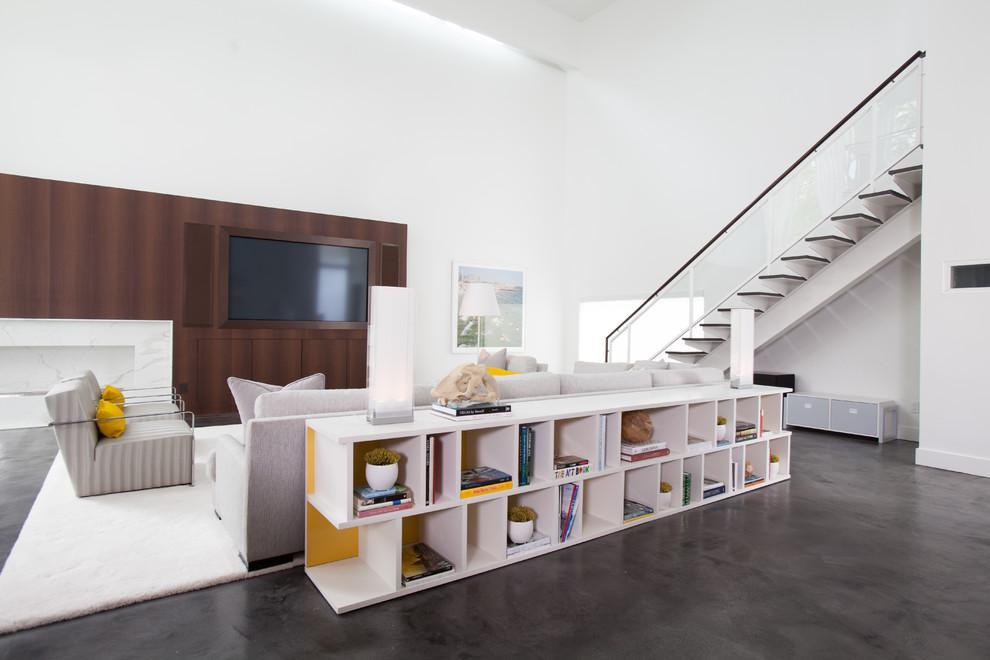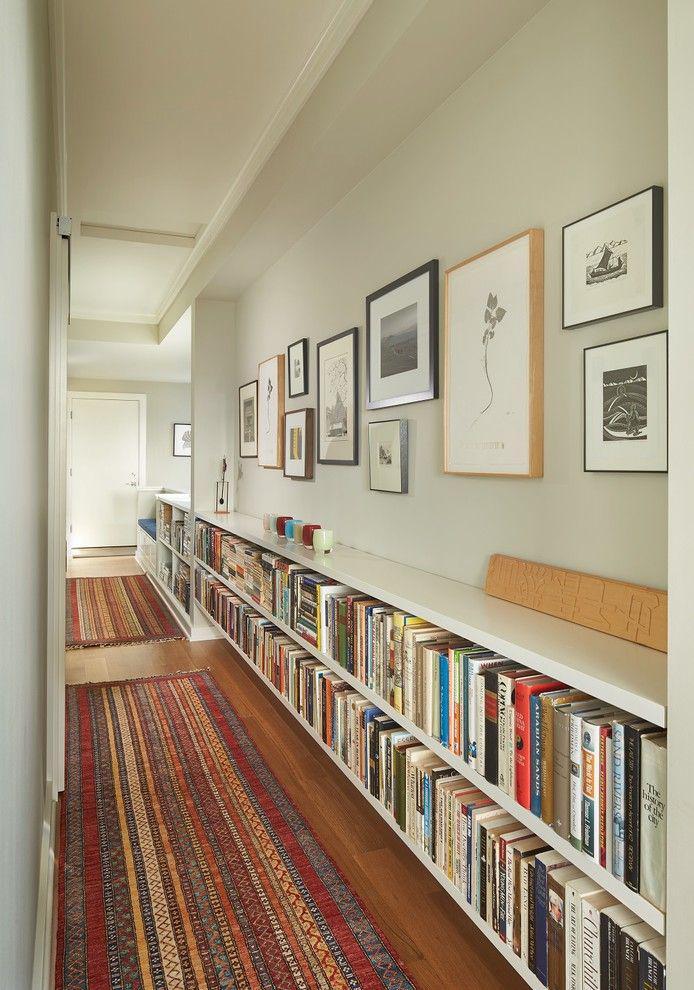The first image is the image on the left, the second image is the image on the right. For the images displayed, is the sentence "An image includes an empty white shelf unit with two layers of staggered compartments." factually correct? Answer yes or no. No. The first image is the image on the left, the second image is the image on the right. Analyze the images presented: Is the assertion "All of the bookshelves are empty." valid? Answer yes or no. No. 